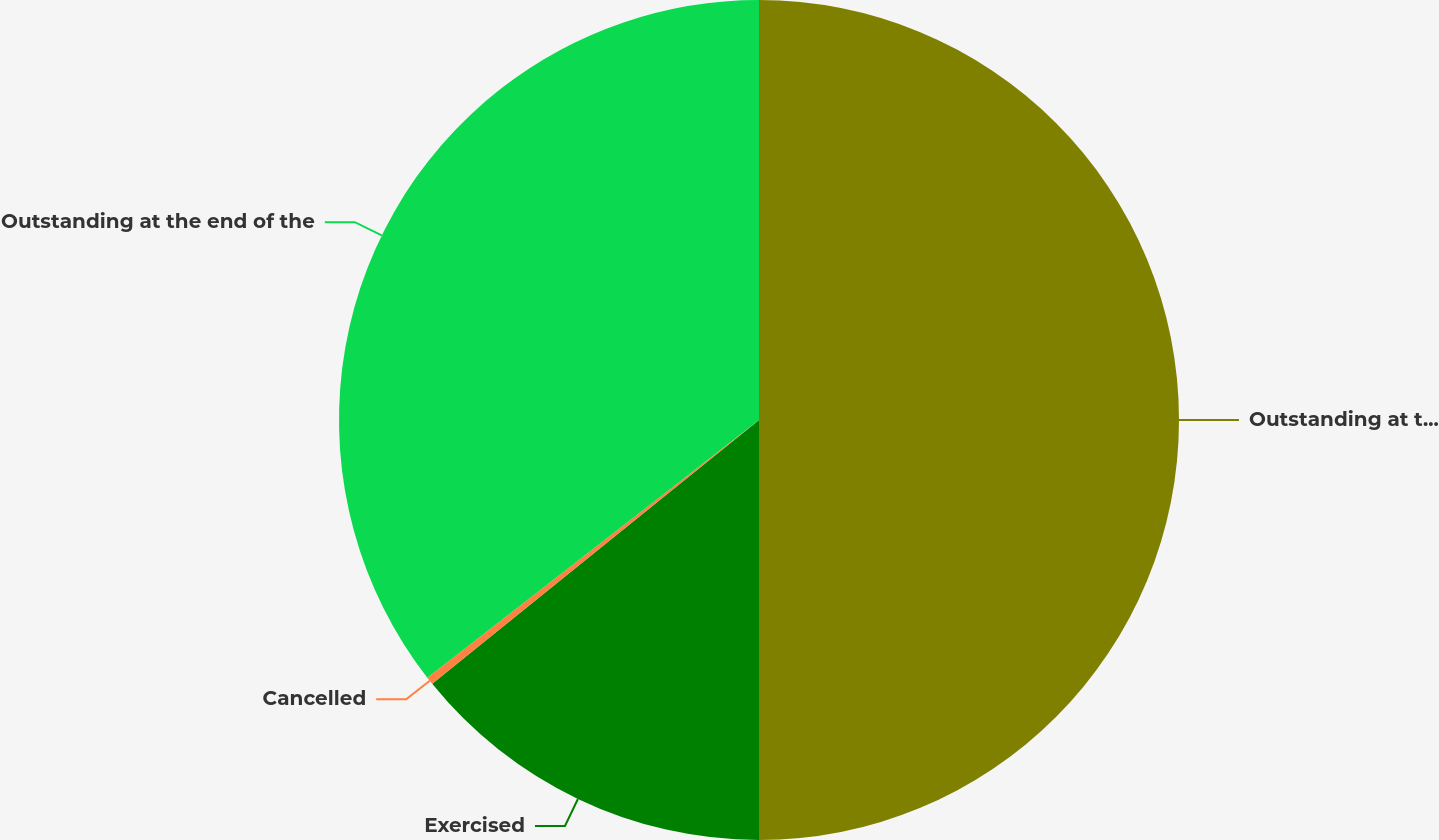Convert chart to OTSL. <chart><loc_0><loc_0><loc_500><loc_500><pie_chart><fcel>Outstanding at the beginning<fcel>Exercised<fcel>Cancelled<fcel>Outstanding at the end of the<nl><fcel>50.0%<fcel>14.19%<fcel>0.3%<fcel>35.51%<nl></chart> 